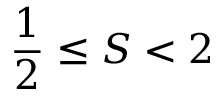<formula> <loc_0><loc_0><loc_500><loc_500>{ \frac { 1 } { 2 } } \leq S < 2</formula> 